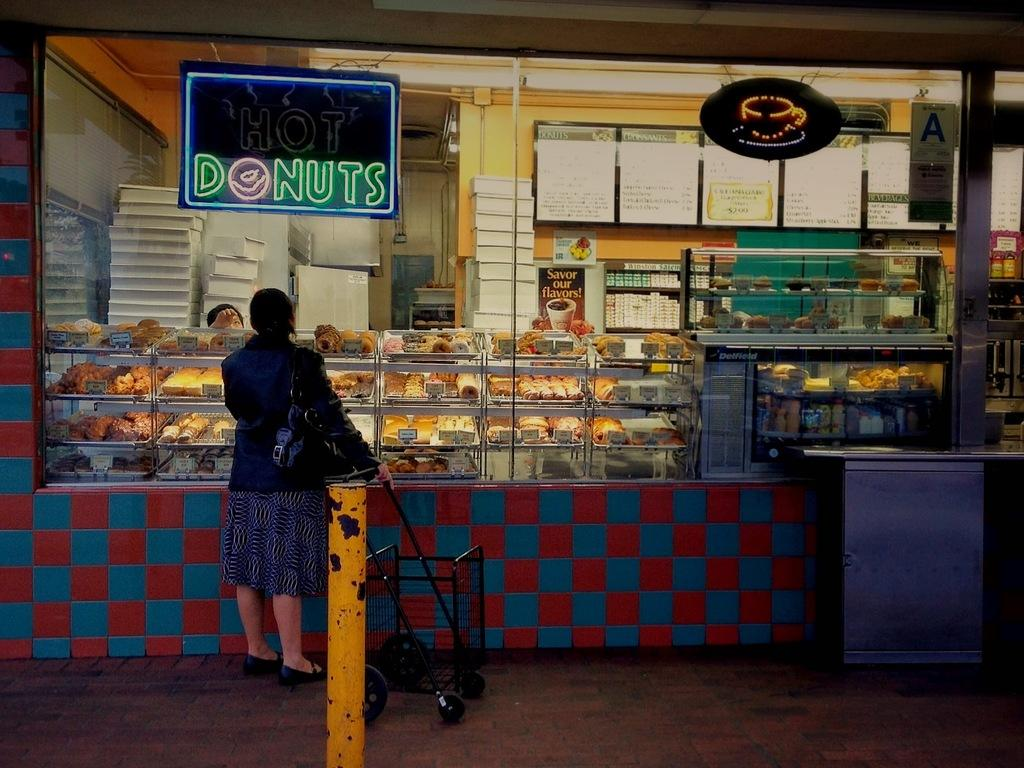<image>
Describe the image concisely. A woman stands at a counter that advertises donuts with a lighted neon sign. 